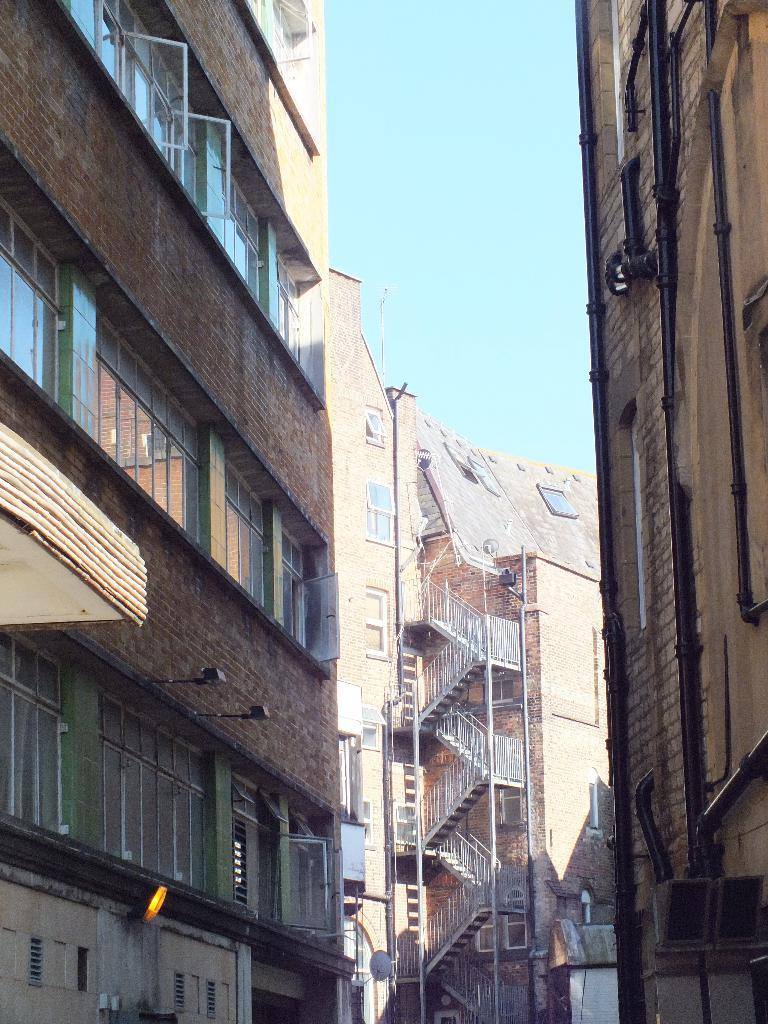What type of structures are present in the image? There are buildings in the image. What features can be seen on the buildings? The buildings have pipes, windows, and staircases. What can be seen in the background of the image? The sky is visible behind the buildings. How many degrees of loss can be observed in the image? There is no mention of loss or degrees in the image, as it features buildings with various features and the sky in the background. 